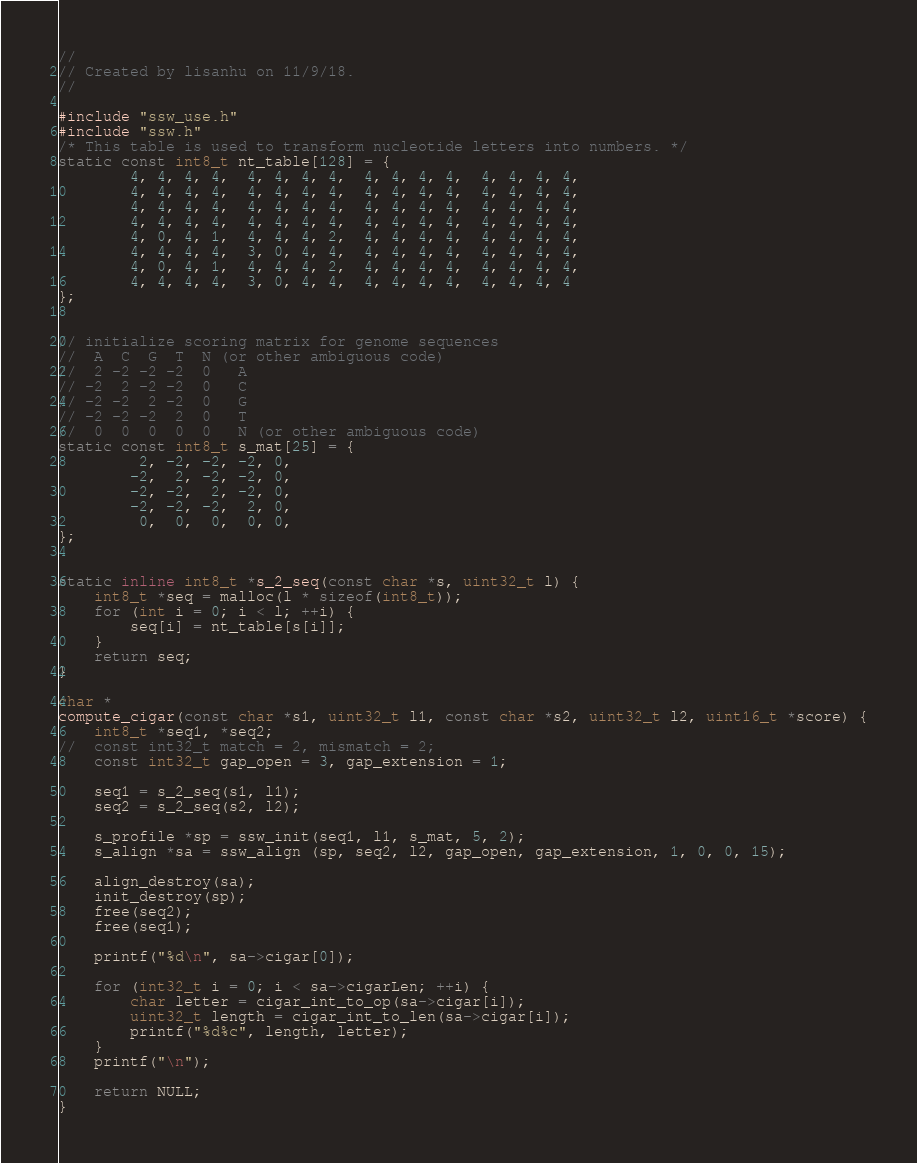Convert code to text. <code><loc_0><loc_0><loc_500><loc_500><_C_>//
// Created by lisanhu on 11/9/18.
//

#include "ssw_use.h"
#include "ssw.h"
/* This table is used to transform nucleotide letters into numbers. */
static const int8_t nt_table[128] = {
		4, 4, 4, 4,  4, 4, 4, 4,  4, 4, 4, 4,  4, 4, 4, 4,
		4, 4, 4, 4,  4, 4, 4, 4,  4, 4, 4, 4,  4, 4, 4, 4,
		4, 4, 4, 4,  4, 4, 4, 4,  4, 4, 4, 4,  4, 4, 4, 4,
		4, 4, 4, 4,  4, 4, 4, 4,  4, 4, 4, 4,  4, 4, 4, 4,
		4, 0, 4, 1,  4, 4, 4, 2,  4, 4, 4, 4,  4, 4, 4, 4,
		4, 4, 4, 4,  3, 0, 4, 4,  4, 4, 4, 4,  4, 4, 4, 4,
		4, 0, 4, 1,  4, 4, 4, 2,  4, 4, 4, 4,  4, 4, 4, 4,
		4, 4, 4, 4,  3, 0, 4, 4,  4, 4, 4, 4,  4, 4, 4, 4
};


// initialize scoring matrix for genome sequences
//  A  C  G  T	N (or other ambiguous code)
//  2 -2 -2 -2 	0	A
// -2  2 -2 -2 	0	C
// -2 -2  2 -2 	0	G
// -2 -2 -2  2 	0	T
//	0  0  0  0  0	N (or other ambiguous code)
static const int8_t s_mat[25] = {
		 2, -2, -2, -2, 0,
		-2,  2, -2, -2, 0,
		-2, -2,  2, -2, 0,
		-2, -2, -2,  2, 0,
		 0,  0,  0,  0, 0,
};


static inline int8_t *s_2_seq(const char *s, uint32_t l) {
	int8_t *seq = malloc(l * sizeof(int8_t));
	for (int i = 0; i < l; ++i) {
		seq[i] = nt_table[s[i]];
	}
	return seq;
}

char *
compute_cigar(const char *s1, uint32_t l1, const char *s2, uint32_t l2, uint16_t *score) {
	int8_t *seq1, *seq2;
//	const int32_t match = 2, mismatch = 2;
	const int32_t gap_open = 3, gap_extension = 1;

	seq1 = s_2_seq(s1, l1);
	seq2 = s_2_seq(s2, l2);

	s_profile *sp = ssw_init(seq1, l1, s_mat, 5, 2);
	s_align *sa = ssw_align (sp, seq2, l2, gap_open, gap_extension, 1, 0, 0, 15);

	align_destroy(sa);
	init_destroy(sp);
	free(seq2);
	free(seq1);

	printf("%d\n", sa->cigar[0]);

	for (int32_t i = 0; i < sa->cigarLen; ++i) {
		char letter = cigar_int_to_op(sa->cigar[i]);
		uint32_t length = cigar_int_to_len(sa->cigar[i]);
		printf("%d%c", length, letter);
	}
	printf("\n");

	return NULL;
}
</code> 